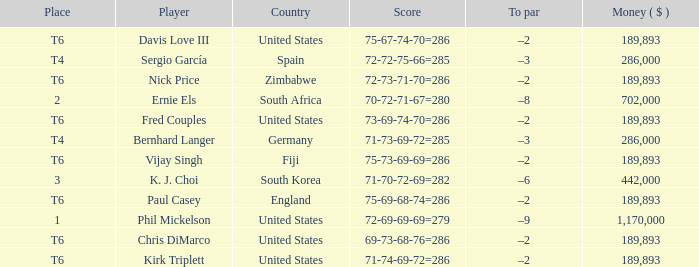What is the least money ($) when the country is united states and the player is kirk triplett? 189893.0. 